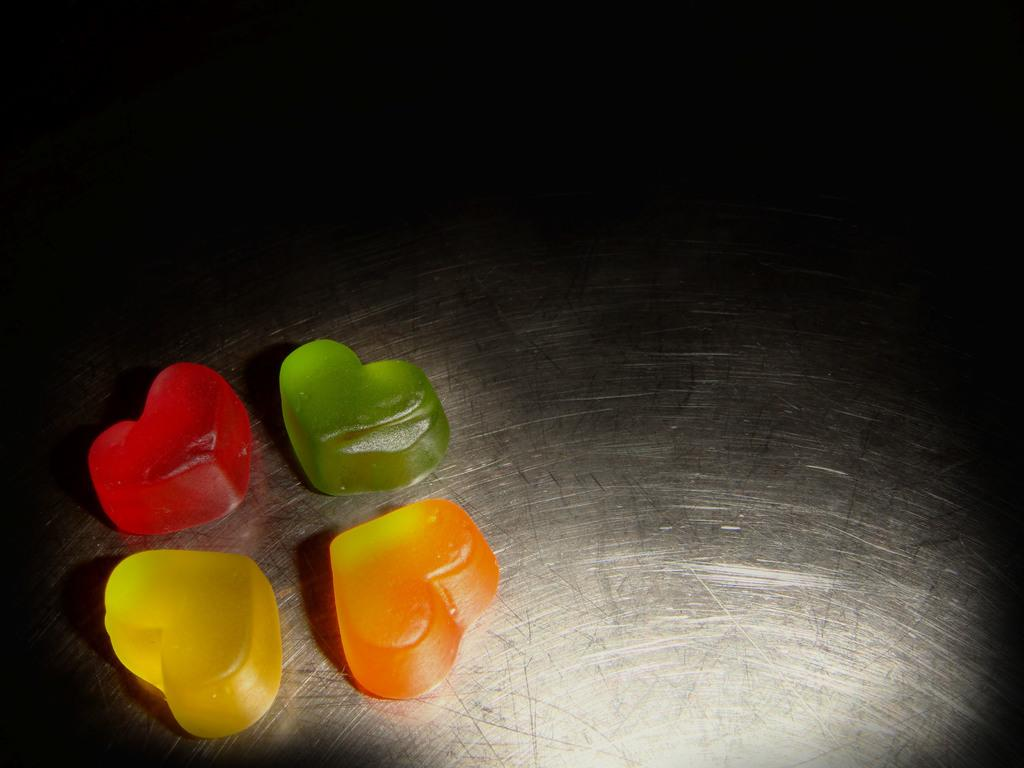What type of food is present in the image? There are jelly in the image. What colors can be seen in the jelly? The jelly are in red, green, orange, and yellow colors. What is the color of the surface in the image? The surface in the image is black and white. What type of action is taking place on the coast in the image? There is no coast or action present in the image; it features jelly on a black and white surface. What type of toys can be seen in the image? There are no toys present in the image; it features jelly on a black and white surface. 